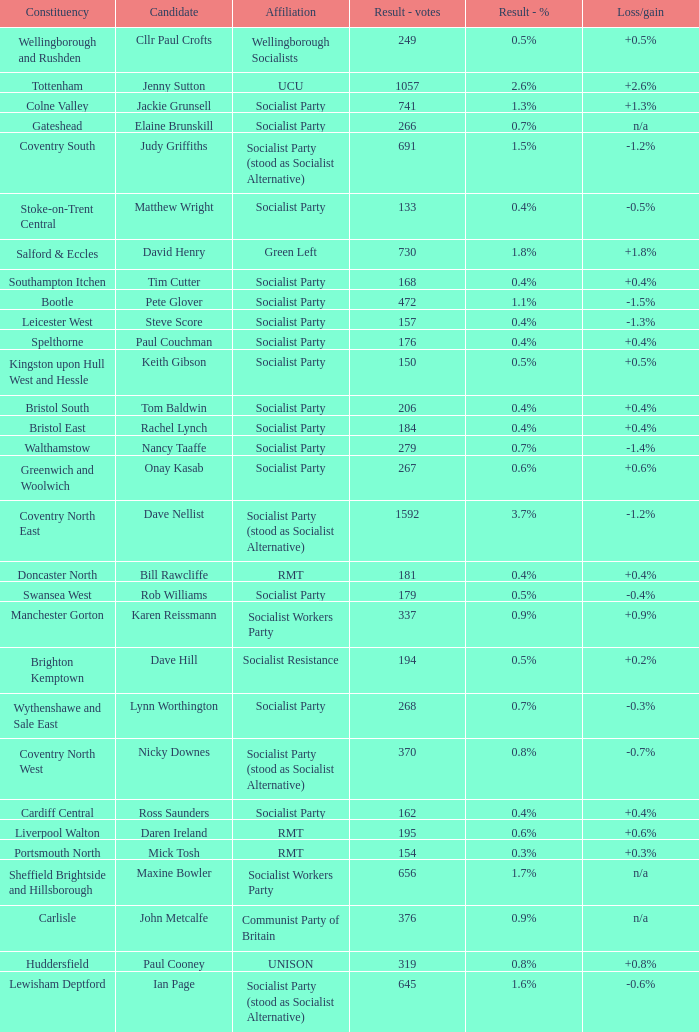What is every affiliation for the Tottenham constituency? UCU. 